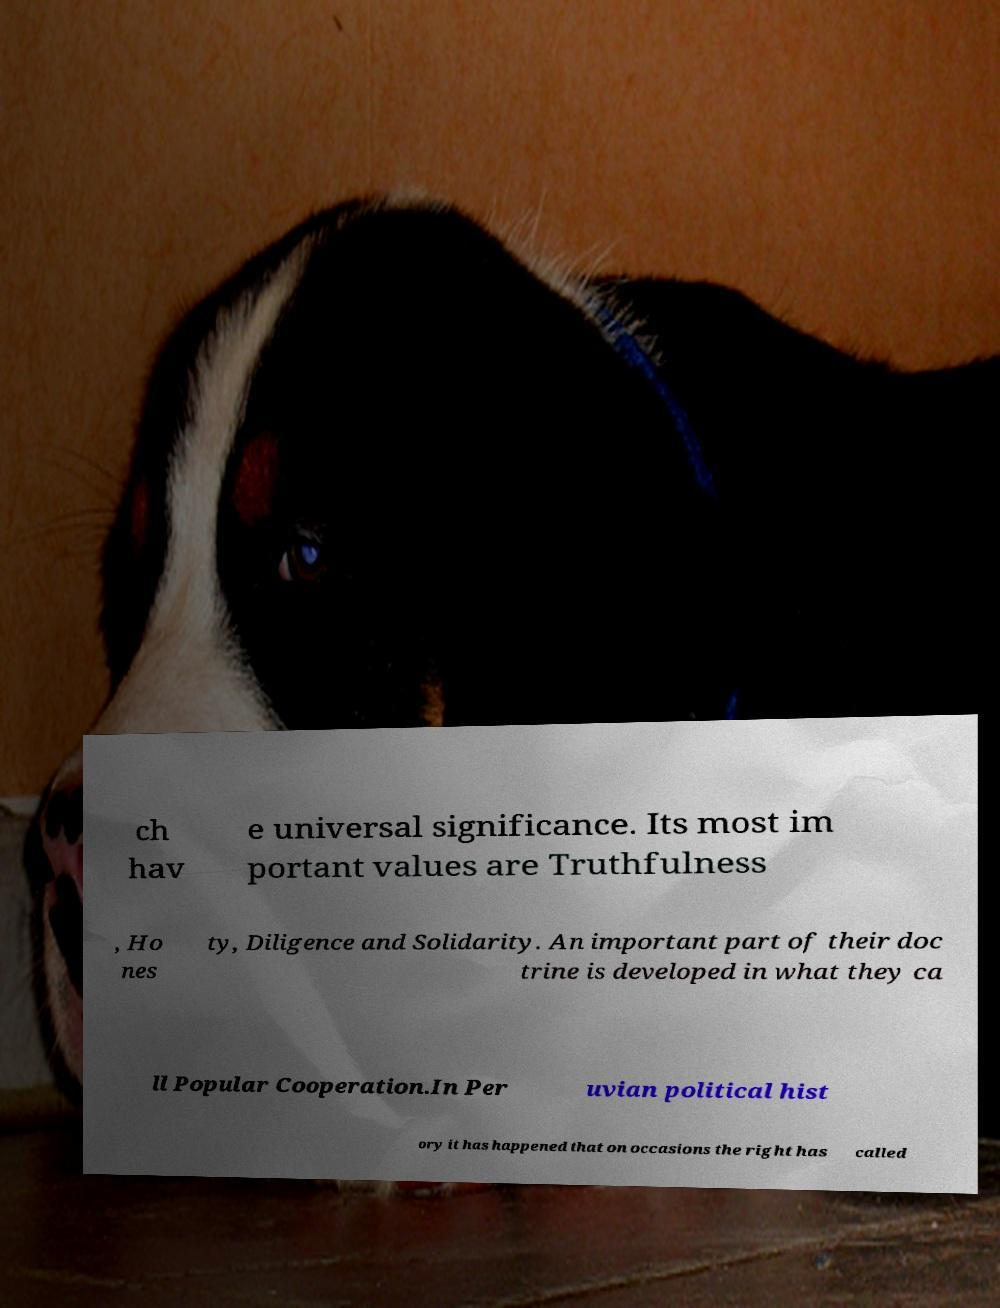There's text embedded in this image that I need extracted. Can you transcribe it verbatim? ch hav e universal significance. Its most im portant values are Truthfulness , Ho nes ty, Diligence and Solidarity. An important part of their doc trine is developed in what they ca ll Popular Cooperation.In Per uvian political hist ory it has happened that on occasions the right has called 